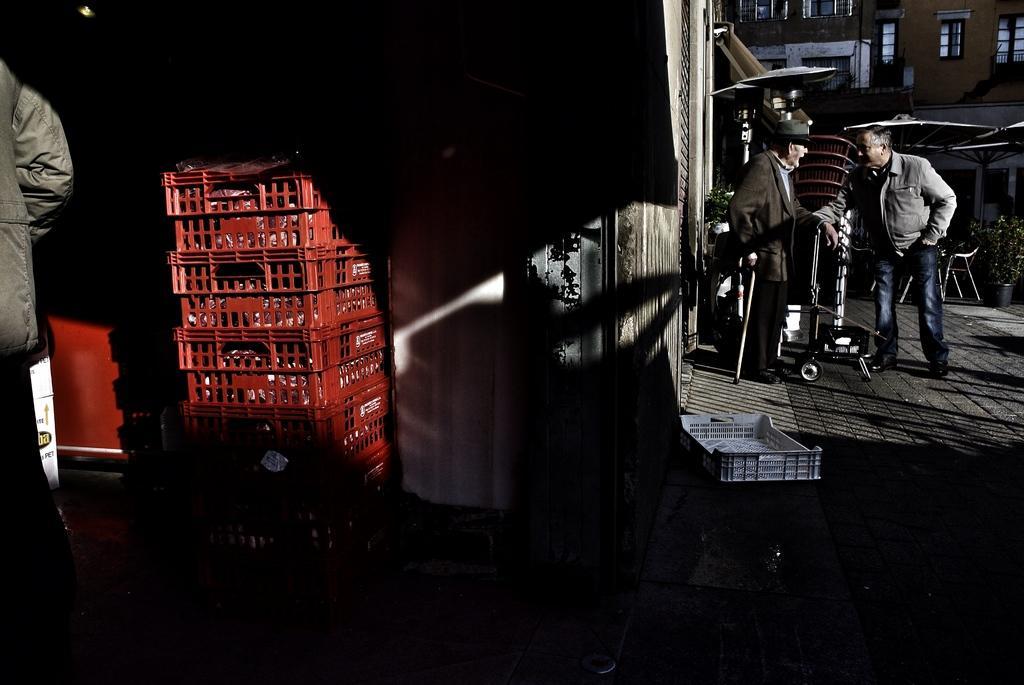In one or two sentences, can you explain what this image depicts? There is a store and many baskets are kept one upon another and on the right side two people were standing and talking to each other, behind them there is a huge building in front of the building there are small plants and on the left side beside the baskets there is another person, he is standing in the dark place. 